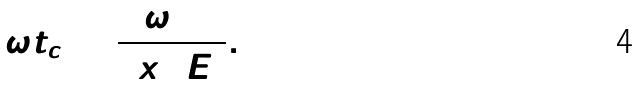Convert formula to latex. <formula><loc_0><loc_0><loc_500><loc_500>\omega t _ { c } = \frac { \omega _ { 1 0 } } { 2 x _ { 1 0 } E _ { 0 } } .</formula> 